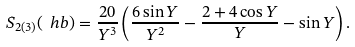Convert formula to latex. <formula><loc_0><loc_0><loc_500><loc_500>S _ { 2 ( 3 ) } ( \ h b ) = \frac { 2 0 } { Y ^ { 3 } } \left ( \frac { 6 \sin Y } { Y ^ { 2 } } - \frac { 2 + 4 \cos Y } { Y } - \sin Y \right ) .</formula> 